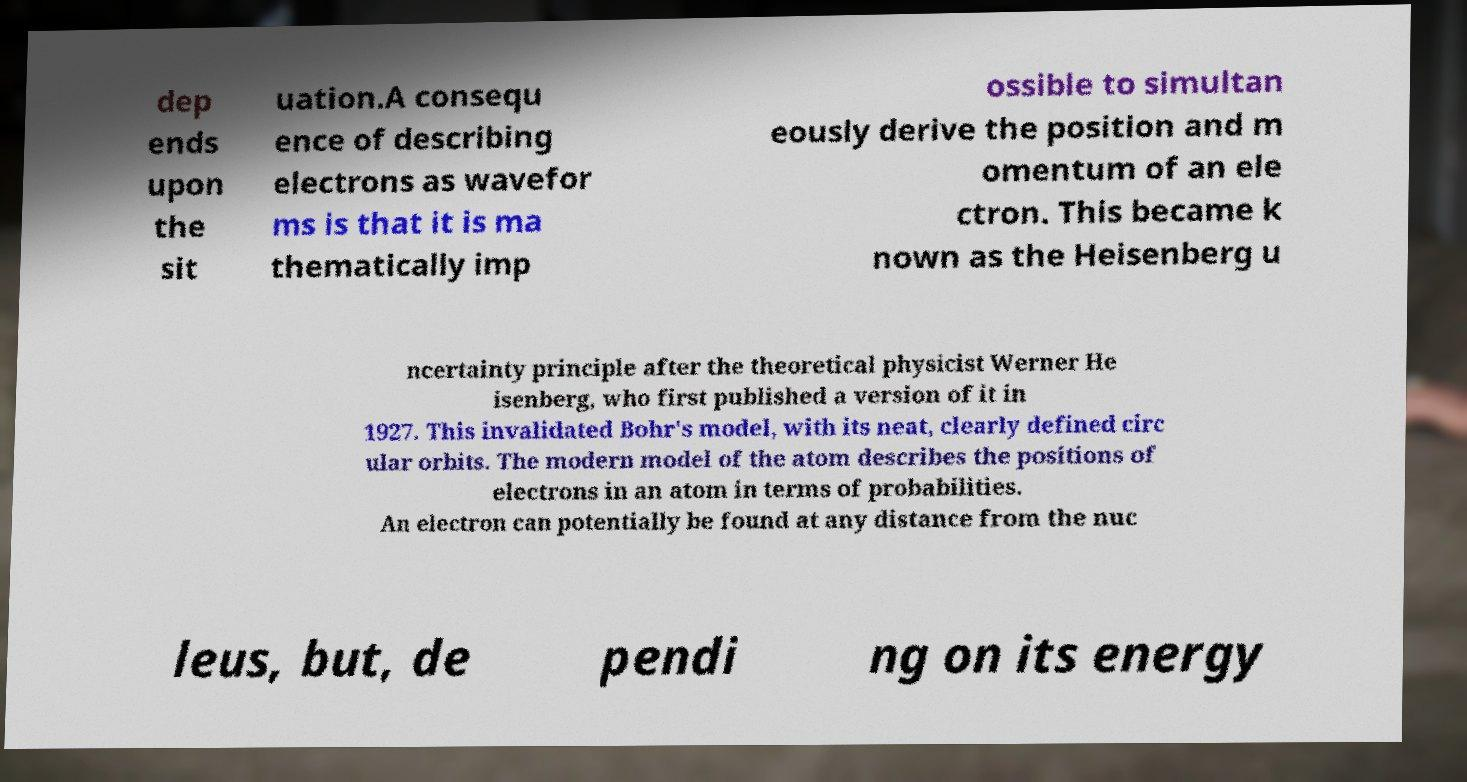Could you assist in decoding the text presented in this image and type it out clearly? dep ends upon the sit uation.A consequ ence of describing electrons as wavefor ms is that it is ma thematically imp ossible to simultan eously derive the position and m omentum of an ele ctron. This became k nown as the Heisenberg u ncertainty principle after the theoretical physicist Werner He isenberg, who first published a version of it in 1927. This invalidated Bohr's model, with its neat, clearly defined circ ular orbits. The modern model of the atom describes the positions of electrons in an atom in terms of probabilities. An electron can potentially be found at any distance from the nuc leus, but, de pendi ng on its energy 